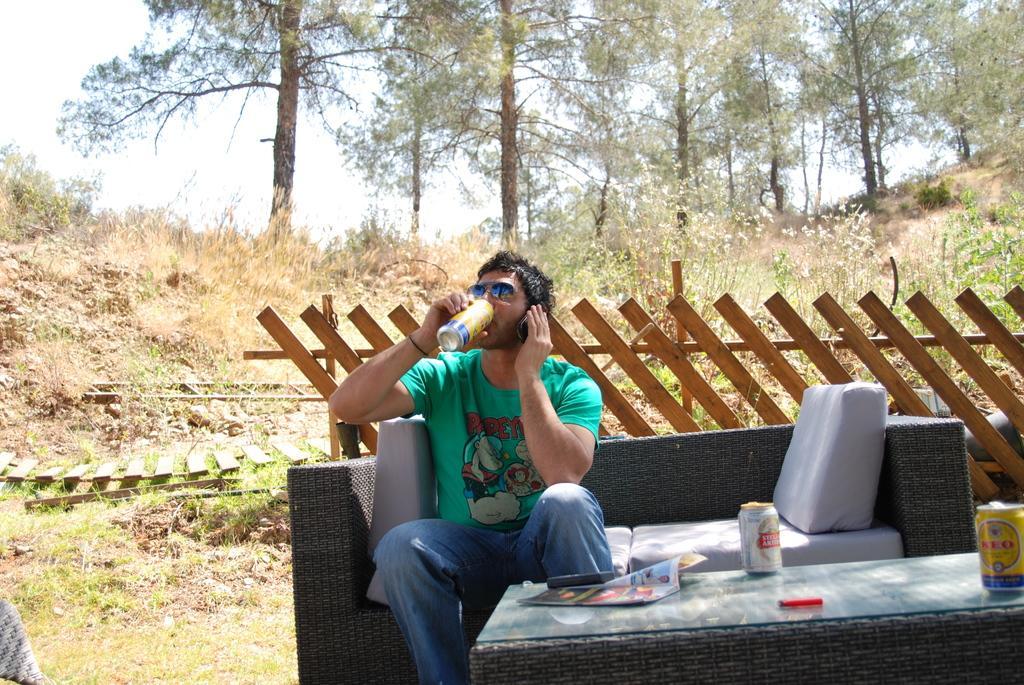Could you give a brief overview of what you see in this image? In this picture, we see the man is sitting on the sofa. He is holding the mobile phone and the coke bottle in his hands. He is drinking the coke from the coke bottle. In front of him, we see a table on which coke bottles, red color object and a book are placed. Behind him, we see the wooden fence. At the bottom, we see the grass. There are trees in the background. At the top, we see the sky. 